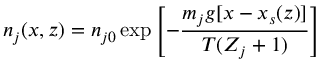Convert formula to latex. <formula><loc_0><loc_0><loc_500><loc_500>n _ { j } ( x , z ) = n _ { j 0 } \exp \left [ - { \frac { m _ { j } g [ x - x _ { s } ( z ) ] } { T ( Z _ { j } + 1 ) } } \right ]</formula> 